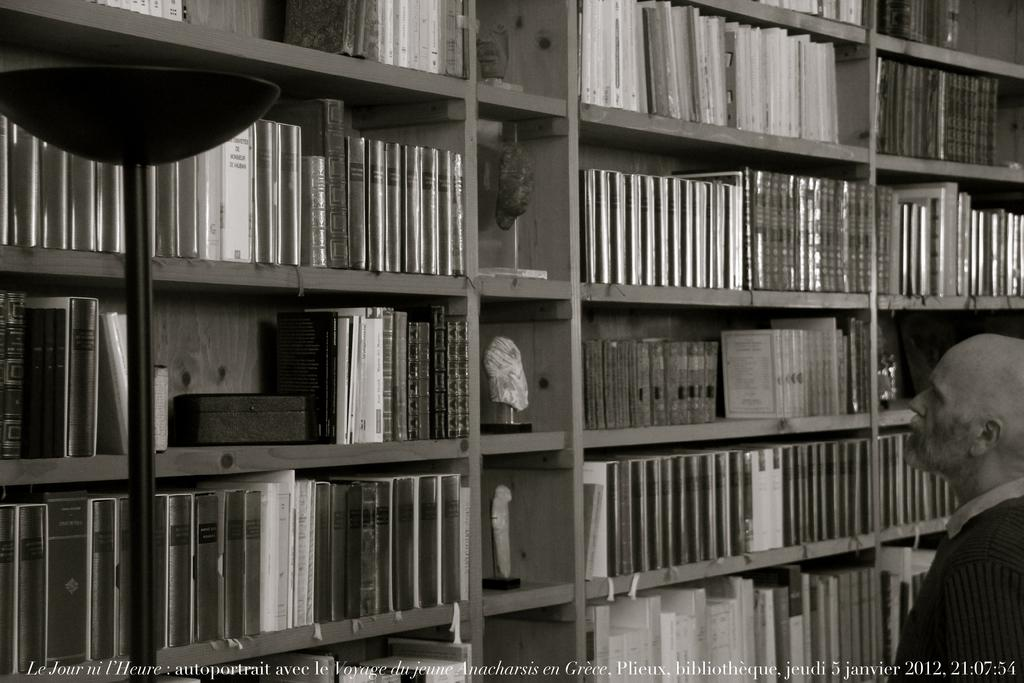What type of text can be seen at the bottom of the image? There is white color text at the bottom of the image. What objects are on the left side of the image? There are books and other objects on the left side of the image. What is the person on the right side of the image doing? The person is watching the objects on the left side. What type of wool is being used by the person in the image? There is no wool present in the image; the person is watching objects on the left side. What type of work is the person doing in the image? The person is not shown doing any work in the image; they are watching objects on the left side. 